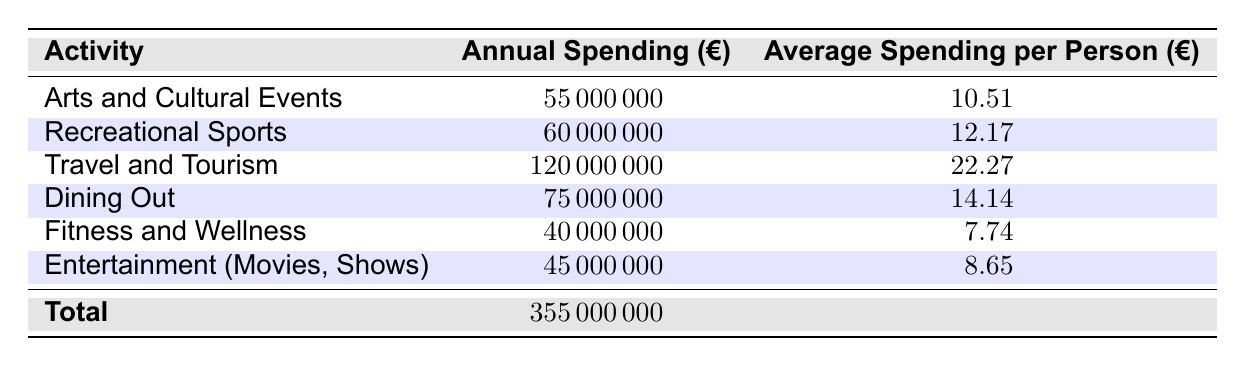What's the total annual spending on leisure activities in Finland in 2022? The table includes a row labeled "Total" that summarizes the overall spending, which is listed as 355,000,000 euros.
Answer: 355000000 What is the average spending per person on travel and tourism? The table displays the average spending per person for travel and tourism as 22.27 euros.
Answer: 22.27 Which leisure activity had the highest annual spending? The activities in the table can be compared based on their annual spending values. Travel and tourism, with 120,000,000 euros, is the highest.
Answer: Travel and Tourism How much more was spent on dining out compared to fitness and wellness? To find the difference, we subtract the annual spending for fitness and wellness (40,000,000 euros) from that of dining out (75,000,000 euros). The difference is 75,000,000 - 40,000,000 = 35,000,000 euros.
Answer: 35000000 Is average spending per person on arts and cultural events greater than for entertainment (movies, shows)? The average spending for arts and cultural events is 10.51 euros, while for entertainment (movies, shows) it is 8.65 euros. Since 10.51 is greater than 8.65, the statement is true.
Answer: Yes What is the total spending on recreational sports and fitness and wellness combined? First, we identify the annual spending for recreational sports (60,000,000 euros) and for fitness and wellness (40,000,000 euros). Adding these amounts gives us 60,000,000 + 40,000,000 = 100,000,000 euros.
Answer: 100000000 How much does the average spending per person for dining out differ from that of arts and cultural events? The average spending for dining out is 14.14 euros, while for arts and cultural events it is 10.51 euros. The difference is 14.14 - 10.51 = 3.63 euros, indicating that dining out costs more on average.
Answer: 3.63 Which two activities combined have the lowest average spending per person? Looking at the data, fitness and wellness has an average spending of 7.74 euros and entertainment (movies, shows) has 8.65 euros. The combined average is (7.74 + 8.65) / 2 = 8.19 euros. This comparison shows both are the lowest in average spending per person.
Answer: 8.19 Was more than 70 million euros spent on arts and cultural events and entertainment combined? Adding the spending for arts and cultural events (55,000,000 euros) and entertainment (45000000 euros) gives 55,000,000 + 45,000,000 = 100,000,000 euros, which is greater than 70 million euros.
Answer: Yes 